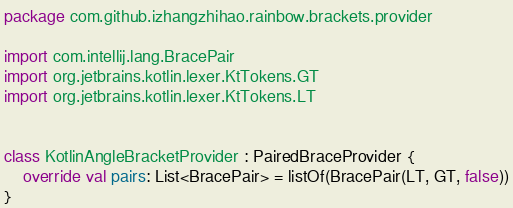Convert code to text. <code><loc_0><loc_0><loc_500><loc_500><_Kotlin_>package com.github.izhangzhihao.rainbow.brackets.provider

import com.intellij.lang.BracePair
import org.jetbrains.kotlin.lexer.KtTokens.GT
import org.jetbrains.kotlin.lexer.KtTokens.LT


class KotlinAngleBracketProvider : PairedBraceProvider {
    override val pairs: List<BracePair> = listOf(BracePair(LT, GT, false))
}</code> 